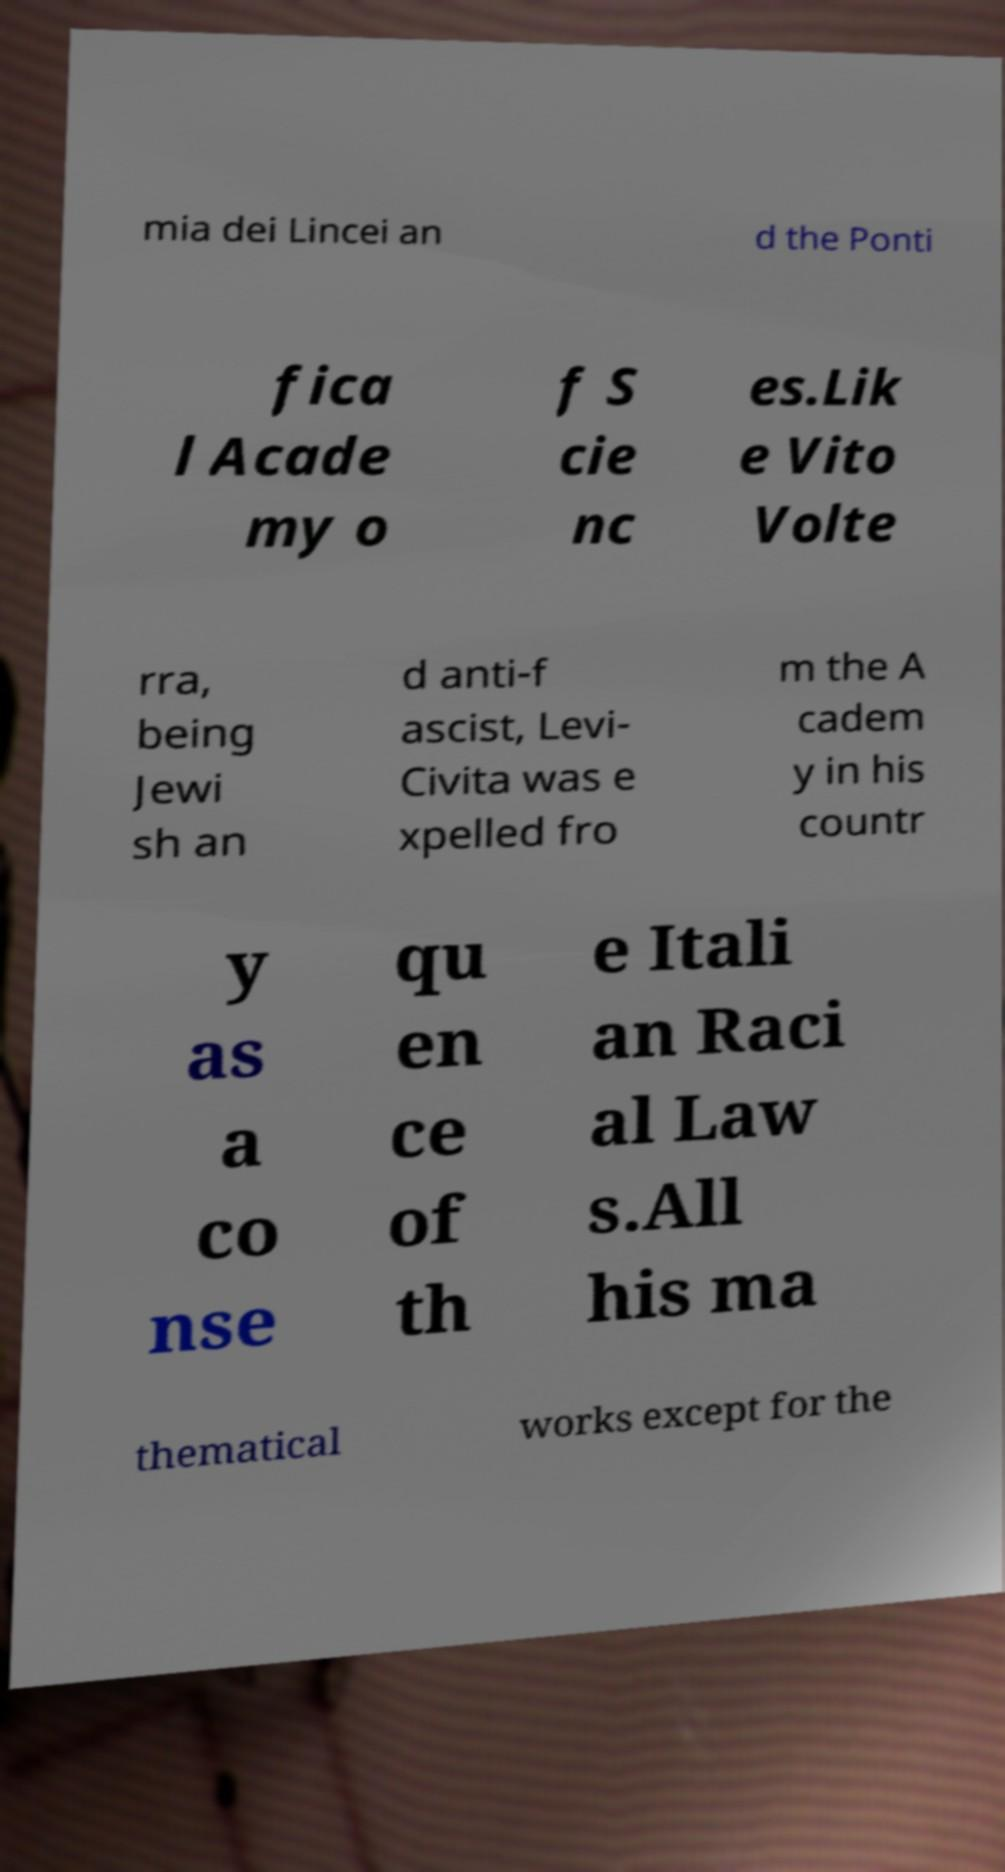Can you accurately transcribe the text from the provided image for me? mia dei Lincei an d the Ponti fica l Acade my o f S cie nc es.Lik e Vito Volte rra, being Jewi sh an d anti-f ascist, Levi- Civita was e xpelled fro m the A cadem y in his countr y as a co nse qu en ce of th e Itali an Raci al Law s.All his ma thematical works except for the 